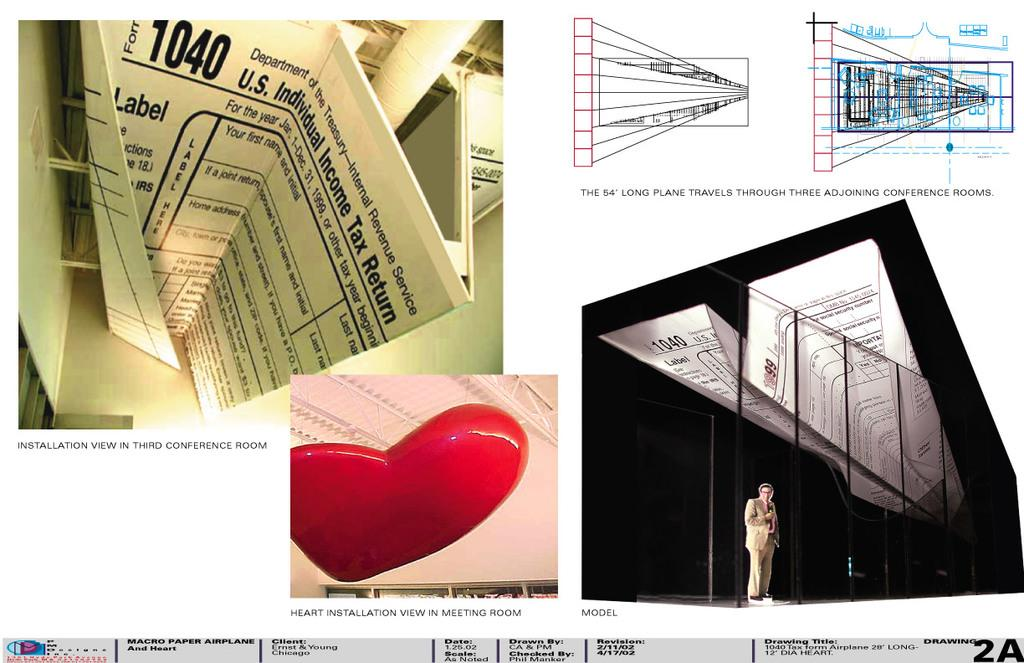<image>
Present a compact description of the photo's key features. A presentation details several types of installation in the THIRD CONVERENCE ROOM, MEETING ROOM, AND THREE ADJOINING CONFERENCE ROOMS. 